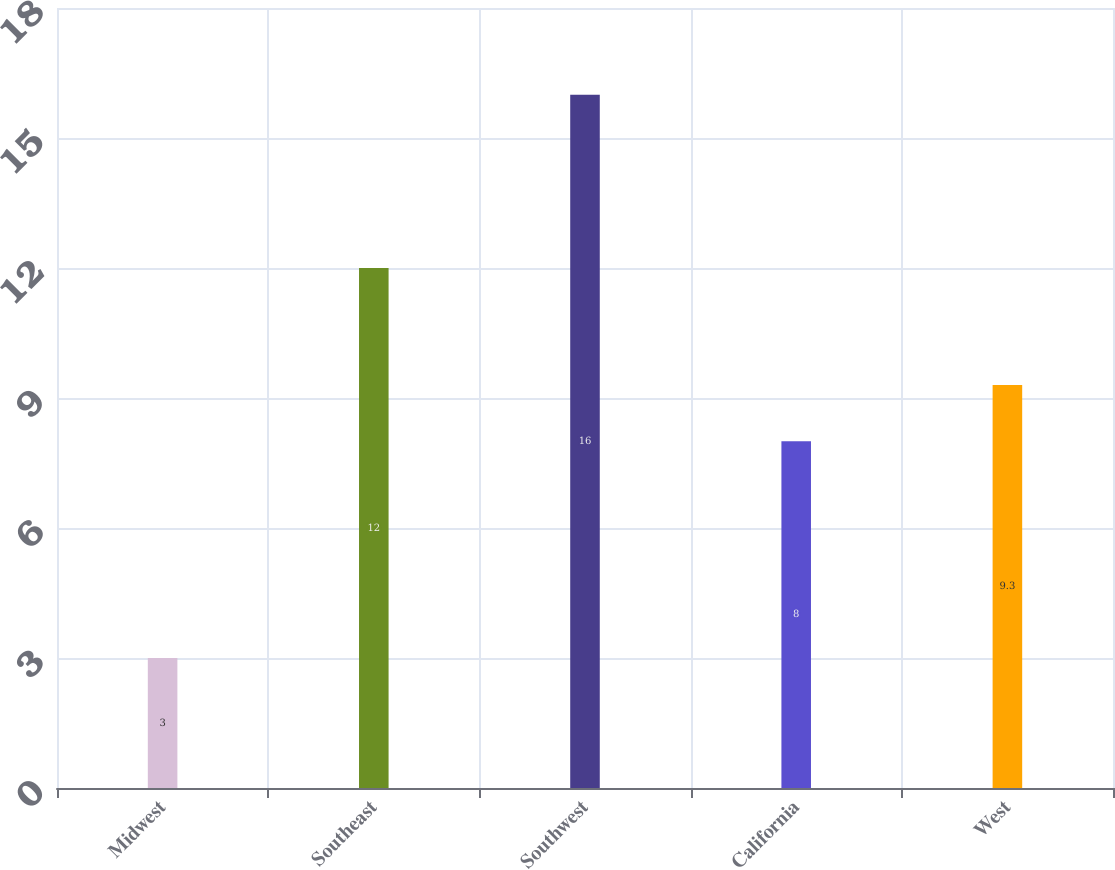Convert chart to OTSL. <chart><loc_0><loc_0><loc_500><loc_500><bar_chart><fcel>Midwest<fcel>Southeast<fcel>Southwest<fcel>California<fcel>West<nl><fcel>3<fcel>12<fcel>16<fcel>8<fcel>9.3<nl></chart> 